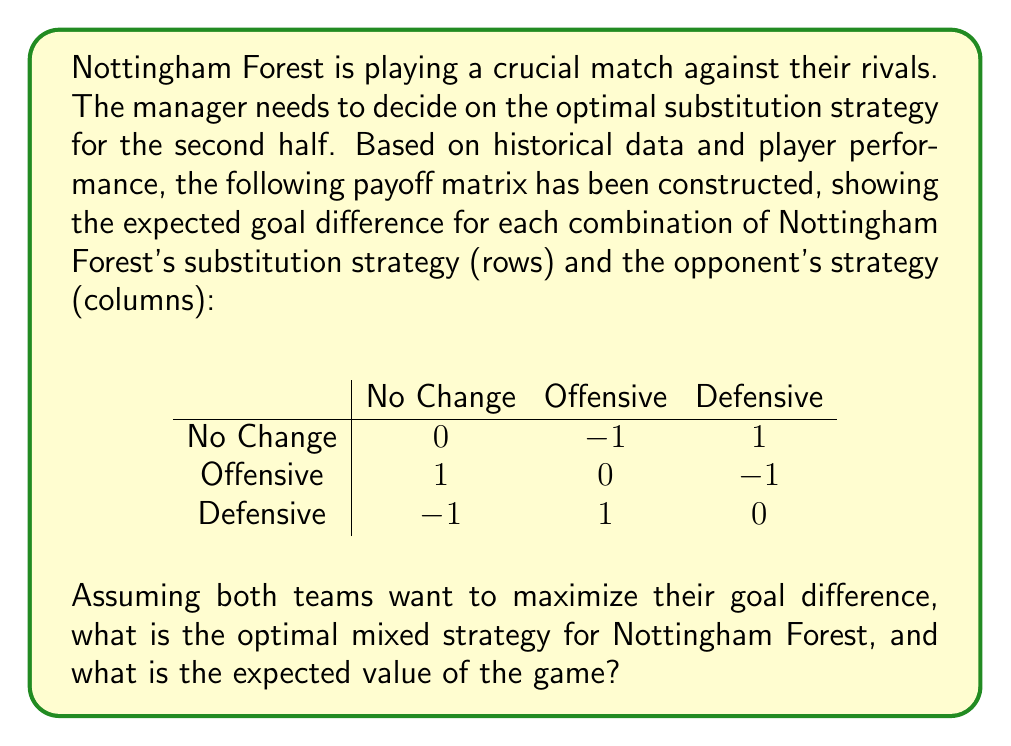Give your solution to this math problem. To solve this problem, we'll use the minimax theorem from game theory:

1) First, we need to check if there's a pure strategy equilibrium. There isn't one, as no cell in the matrix is simultaneously the maximum of its column and minimum of its row.

2) Therefore, we need to find a mixed strategy equilibrium. Let's denote the probabilities of Nottingham Forest choosing No Change, Offensive, and Defensive strategies as $x$, $y$, and $z$ respectively.

3) For a mixed strategy equilibrium, the expected payoff for the opponent should be the same regardless of their choice. This gives us three equations:

   $0x + 1y - 1z = -1x + 0y + 1z = 1x - 1y + 0z$

4) We also know that $x + y + z = 1$ (probabilities sum to 1)

5) Solving this system of equations:

   $x - y = 0$
   $x - z = 0$
   $x + y + z = 1$

6) This gives us: $x = y = z = \frac{1}{3}$

7) The expected value of the game is the same as any of the equations from step 3:

   $0(\frac{1}{3}) + 1(\frac{1}{3}) - 1(\frac{1}{3}) = 0$

Therefore, Nottingham Forest's optimal strategy is to choose each option with equal probability $\frac{1}{3}$, and the expected value of the game is 0.
Answer: Optimal strategy: $(\frac{1}{3}, \frac{1}{3}, \frac{1}{3})$; Expected value: 0 